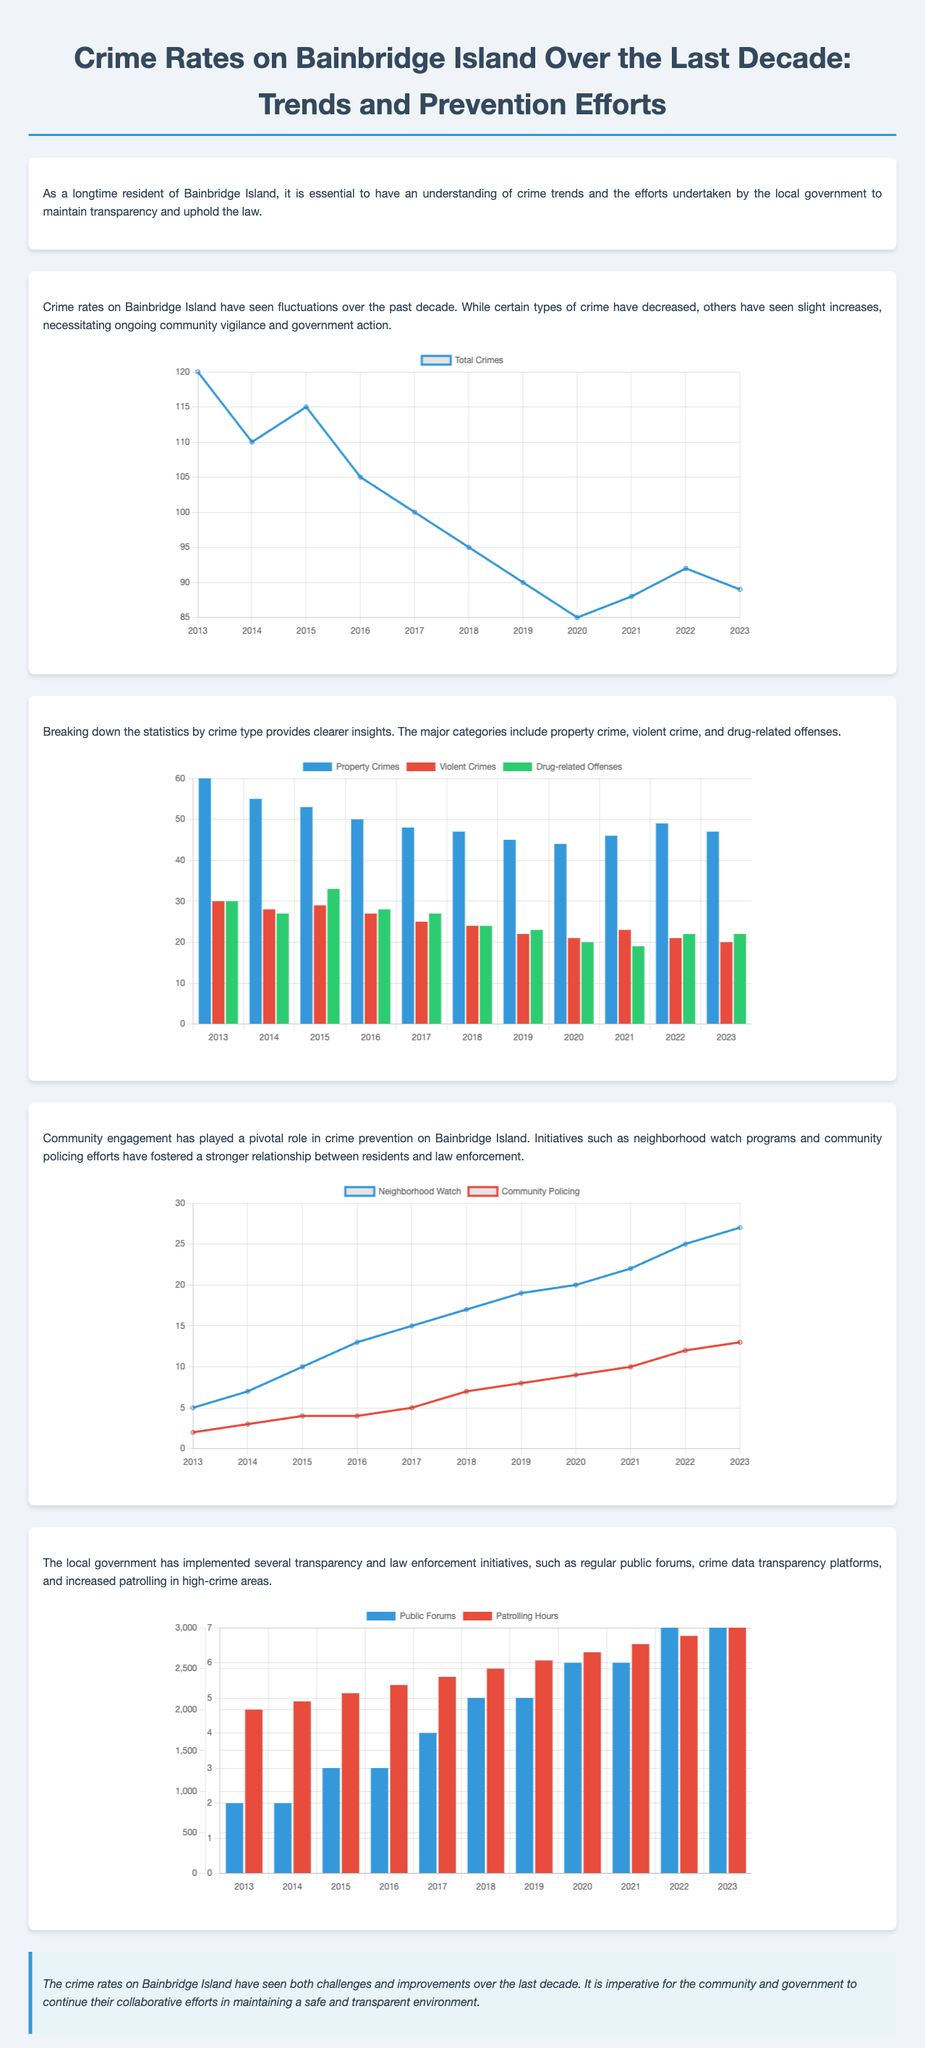What year had the highest total crimes? The highest total crimes reported were in 2013, with a total of 120 crimes.
Answer: 2013 What is the trend of property crimes from 2013 to 2023? Property crimes showed a general declining trend, moving from 60 in 2013 to 47 in 2023.
Answer: Decrease How many participants were in neighborhood watch programs by 2023? The neighborhood watch program participants increased to 27 by 2023.
Answer: 27 What was the total number of violent crimes in 2022? In 2022, the number of violent crimes recorded was 21.
Answer: 21 What is one of the initiatives implemented by the government for crime prevention? One of the initiatives is regular public forums to engage the community.
Answer: Public Forums Which crime type saw the lowest numbers in 2023? In 2023, violent crimes had the lowest number, recorded at 20.
Answer: Violent Crimes What year did the participation in community policing programs reach 13? Community policing participation reached 13 in the year 2023.
Answer: 2023 How many patrolling hours were recorded in 2023? The number of patrolling hours recorded in 2023 was 3000.
Answer: 3000 What was the percentage of decrease in total crimes from 2013 to 2023? The total crimes decreased from 120 to 89, which is a decrease of approximately 25.8%.
Answer: Approximately 25.8% 